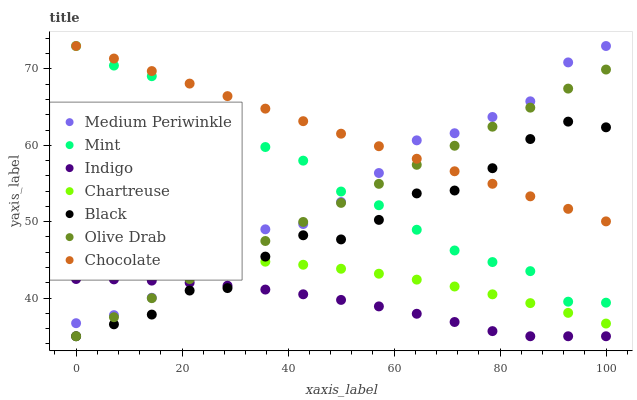Does Indigo have the minimum area under the curve?
Answer yes or no. Yes. Does Chocolate have the maximum area under the curve?
Answer yes or no. Yes. Does Medium Periwinkle have the minimum area under the curve?
Answer yes or no. No. Does Medium Periwinkle have the maximum area under the curve?
Answer yes or no. No. Is Chocolate the smoothest?
Answer yes or no. Yes. Is Black the roughest?
Answer yes or no. Yes. Is Medium Periwinkle the smoothest?
Answer yes or no. No. Is Medium Periwinkle the roughest?
Answer yes or no. No. Does Indigo have the lowest value?
Answer yes or no. Yes. Does Medium Periwinkle have the lowest value?
Answer yes or no. No. Does Mint have the highest value?
Answer yes or no. Yes. Does Chartreuse have the highest value?
Answer yes or no. No. Is Indigo less than Chartreuse?
Answer yes or no. Yes. Is Chartreuse greater than Indigo?
Answer yes or no. Yes. Does Chartreuse intersect Olive Drab?
Answer yes or no. Yes. Is Chartreuse less than Olive Drab?
Answer yes or no. No. Is Chartreuse greater than Olive Drab?
Answer yes or no. No. Does Indigo intersect Chartreuse?
Answer yes or no. No. 